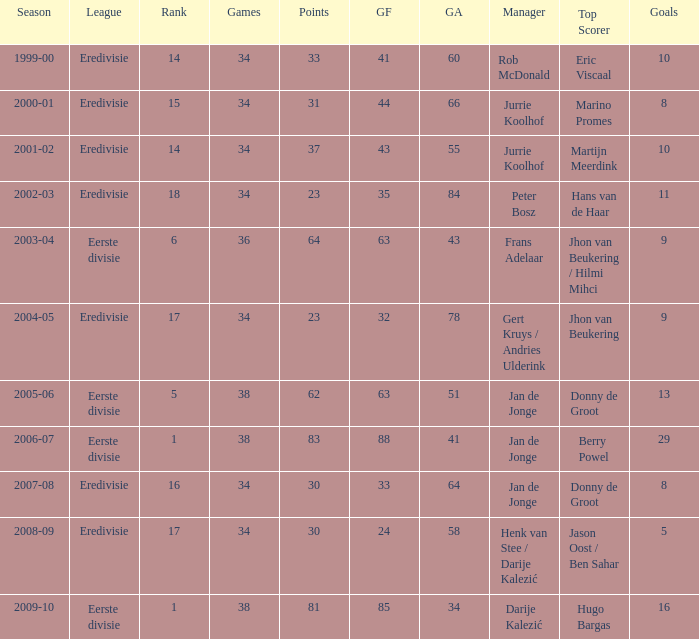What was the total number of goals scored during the 2005-06 season? 13.0. 